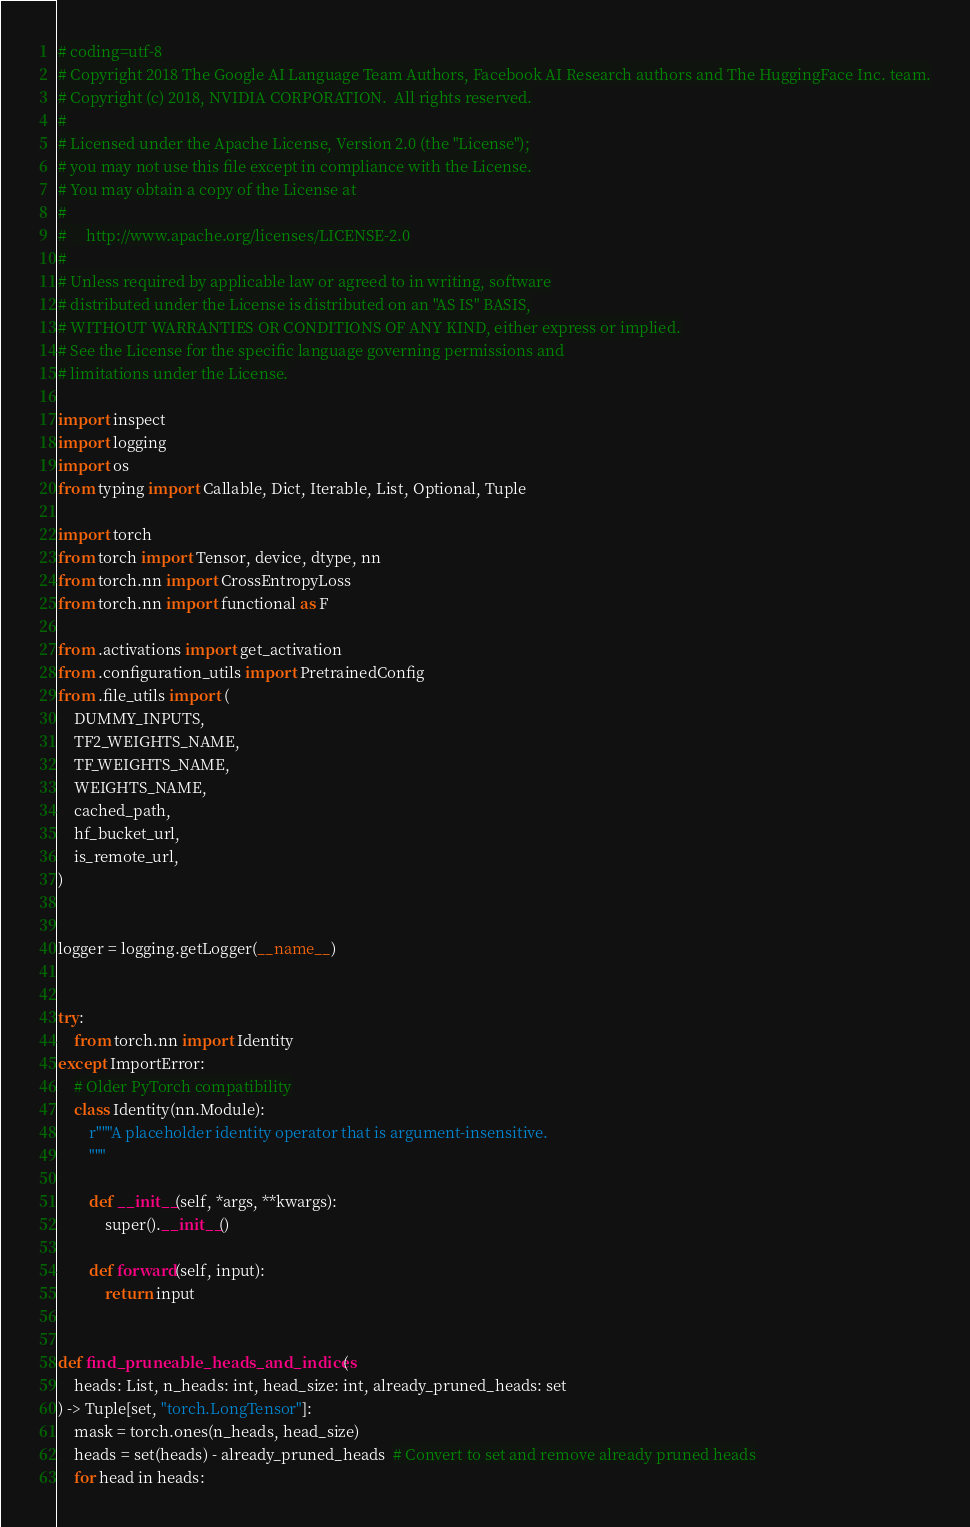Convert code to text. <code><loc_0><loc_0><loc_500><loc_500><_Python_># coding=utf-8
# Copyright 2018 The Google AI Language Team Authors, Facebook AI Research authors and The HuggingFace Inc. team.
# Copyright (c) 2018, NVIDIA CORPORATION.  All rights reserved.
#
# Licensed under the Apache License, Version 2.0 (the "License");
# you may not use this file except in compliance with the License.
# You may obtain a copy of the License at
#
#     http://www.apache.org/licenses/LICENSE-2.0
#
# Unless required by applicable law or agreed to in writing, software
# distributed under the License is distributed on an "AS IS" BASIS,
# WITHOUT WARRANTIES OR CONDITIONS OF ANY KIND, either express or implied.
# See the License for the specific language governing permissions and
# limitations under the License.

import inspect
import logging
import os
from typing import Callable, Dict, Iterable, List, Optional, Tuple

import torch
from torch import Tensor, device, dtype, nn
from torch.nn import CrossEntropyLoss
from torch.nn import functional as F

from .activations import get_activation
from .configuration_utils import PretrainedConfig
from .file_utils import (
    DUMMY_INPUTS,
    TF2_WEIGHTS_NAME,
    TF_WEIGHTS_NAME,
    WEIGHTS_NAME,
    cached_path,
    hf_bucket_url,
    is_remote_url,
)


logger = logging.getLogger(__name__)


try:
    from torch.nn import Identity
except ImportError:
    # Older PyTorch compatibility
    class Identity(nn.Module):
        r"""A placeholder identity operator that is argument-insensitive.
        """

        def __init__(self, *args, **kwargs):
            super().__init__()

        def forward(self, input):
            return input


def find_pruneable_heads_and_indices(
    heads: List, n_heads: int, head_size: int, already_pruned_heads: set
) -> Tuple[set, "torch.LongTensor"]:
    mask = torch.ones(n_heads, head_size)
    heads = set(heads) - already_pruned_heads  # Convert to set and remove already pruned heads
    for head in heads:</code> 